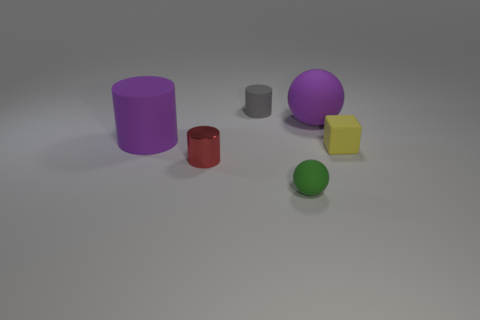Can you describe the lighting and shadows observed in this scene? Certainly. The lighting in this scene appears to be diffused overhead lighting, possibly simulating an overcast day resulting in softly cast shadows. Each object casts a gentle shadow opposite to the light source, providing a moderate sense of depth to the scene. 